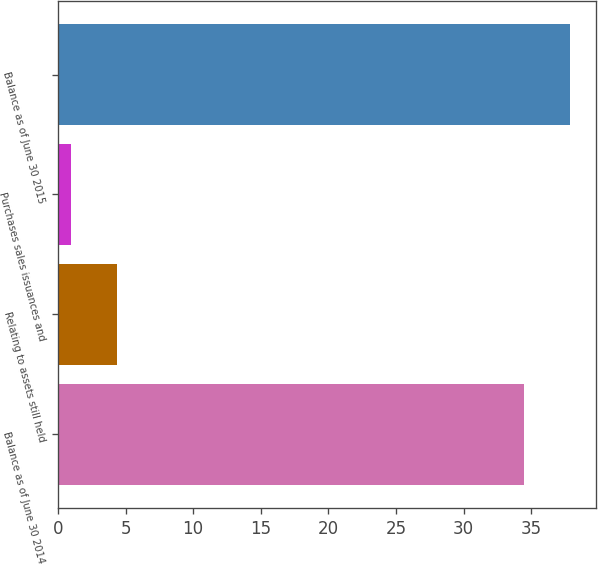Convert chart. <chart><loc_0><loc_0><loc_500><loc_500><bar_chart><fcel>Balance as of June 30 2014<fcel>Relating to assets still held<fcel>Purchases sales issuances and<fcel>Balance as of June 30 2015<nl><fcel>34.5<fcel>4.4<fcel>1<fcel>37.9<nl></chart> 